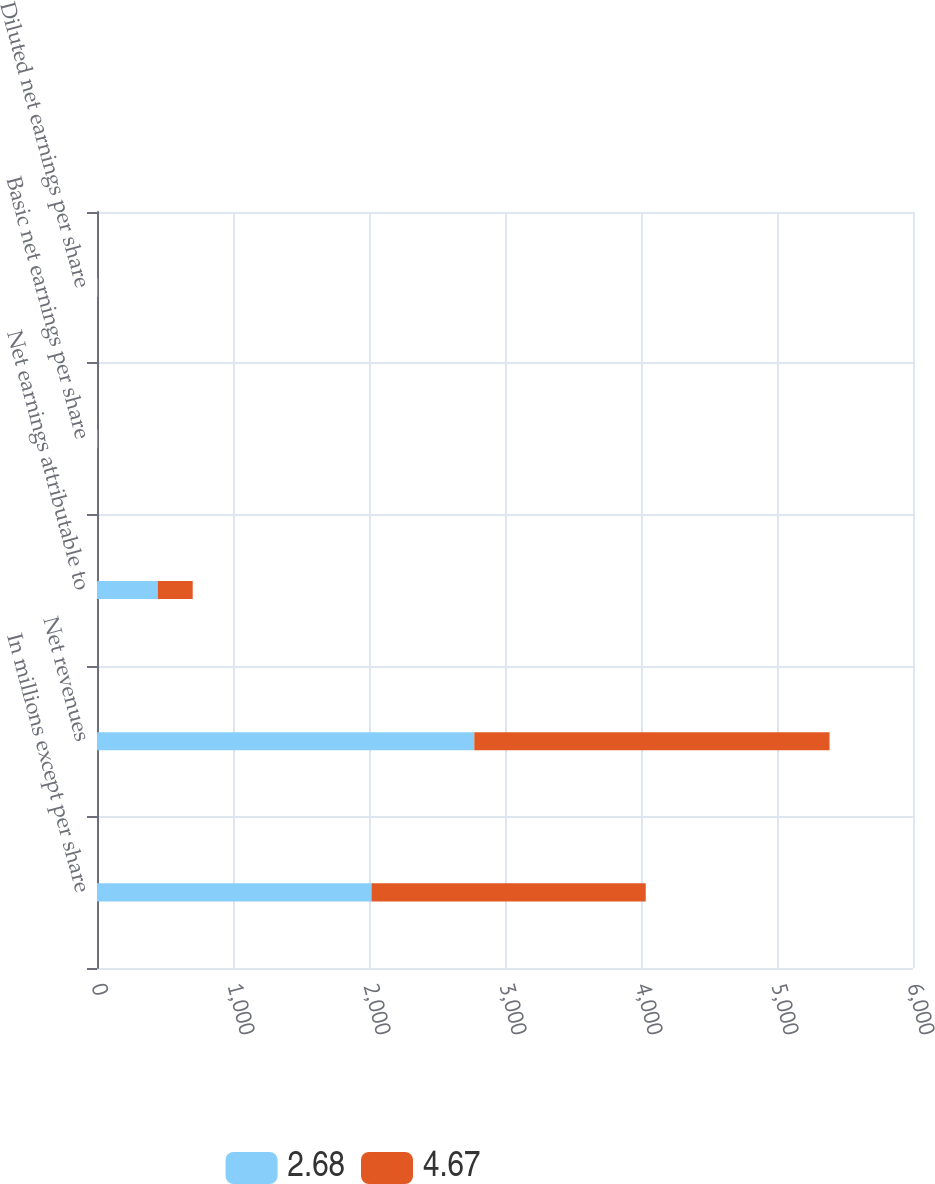Convert chart. <chart><loc_0><loc_0><loc_500><loc_500><stacked_bar_chart><ecel><fcel>In millions except per share<fcel>Net revenues<fcel>Net earnings attributable to<fcel>Basic net earnings per share<fcel>Diluted net earnings per share<nl><fcel>2.68<fcel>2018<fcel>2774.2<fcel>446.8<fcel>4.7<fcel>4.67<nl><fcel>4.67<fcel>2017<fcel>2612.1<fcel>256.9<fcel>2.7<fcel>2.68<nl></chart> 